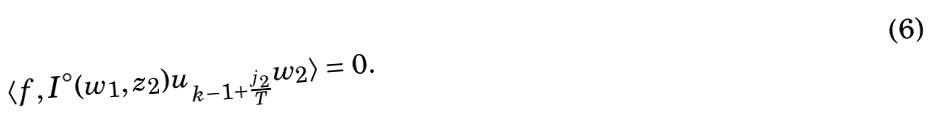Convert formula to latex. <formula><loc_0><loc_0><loc_500><loc_500>\langle f , I ^ { \circ } ( w _ { 1 } , z _ { 2 } ) u _ { k - 1 + \frac { j _ { 2 } } { T } } w _ { 2 } \rangle = 0 .</formula> 